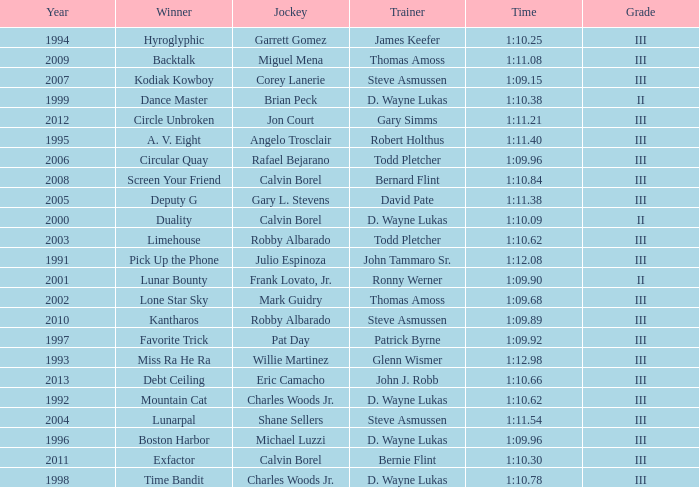Which trainer won the hyroglyphic in a year that was before 2010? James Keefer. 